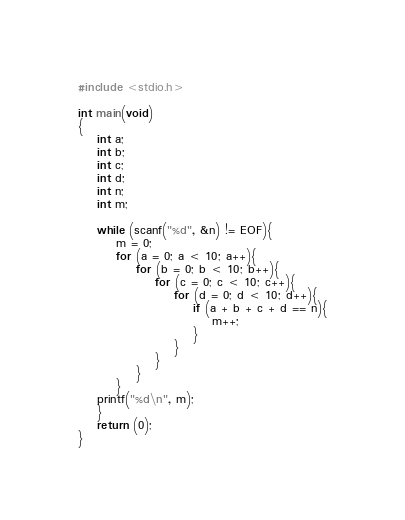Convert code to text. <code><loc_0><loc_0><loc_500><loc_500><_C_>#include <stdio.h>

int main(void)
{
	int a;
	int b;
	int c;
	int d;
	int n;
	int m;
	
	while (scanf("%d", &n) != EOF){
		m = 0;
		for (a = 0; a < 10; a++){
			for (b = 0; b < 10; b++){
				for (c = 0; c < 10; c++){
					for (d = 0; d < 10; d++){
						if (a + b + c + d == n){
							m++;
						}
					}
				}
			}
		}
	printf("%d\n", m);
	}
	return (0);
}</code> 